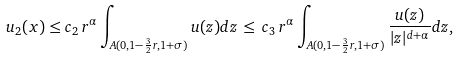<formula> <loc_0><loc_0><loc_500><loc_500>u _ { 2 } ( x ) \leq c _ { 2 } \, r ^ { \alpha } \int _ { A ( 0 , 1 - \frac { 3 } { 2 } r , 1 + \sigma ) } u ( z ) d z \, \leq \, c _ { 3 } \, r ^ { \alpha } \int _ { A ( 0 , 1 - \frac { 3 } { 2 } r , 1 + \sigma ) } \frac { u ( z ) } { | z | ^ { d + \alpha } } d z ,</formula> 